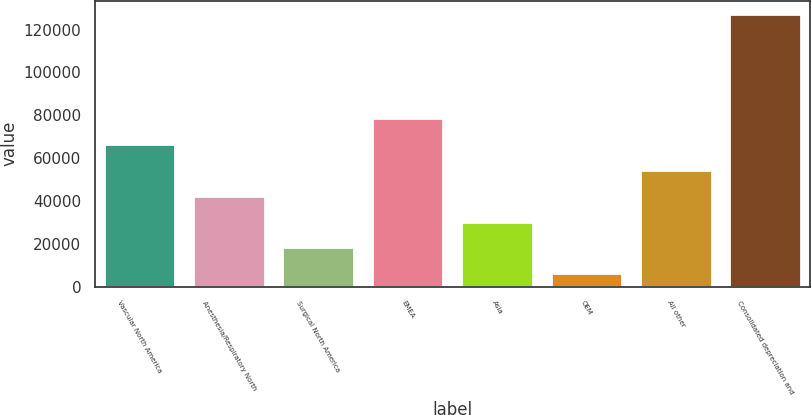<chart> <loc_0><loc_0><loc_500><loc_500><bar_chart><fcel>Vascular North America<fcel>Anesthesia/Respiratory North<fcel>Surgical North America<fcel>EMEA<fcel>Asia<fcel>OEM<fcel>All other<fcel>Consolidated depreciation and<nl><fcel>66602.5<fcel>42431.5<fcel>18260.5<fcel>78688<fcel>30346<fcel>6175<fcel>54517<fcel>127030<nl></chart> 